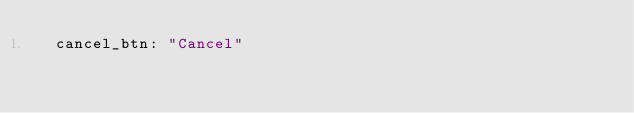Convert code to text. <code><loc_0><loc_0><loc_500><loc_500><_YAML_>  cancel_btn: "Cancel"
</code> 